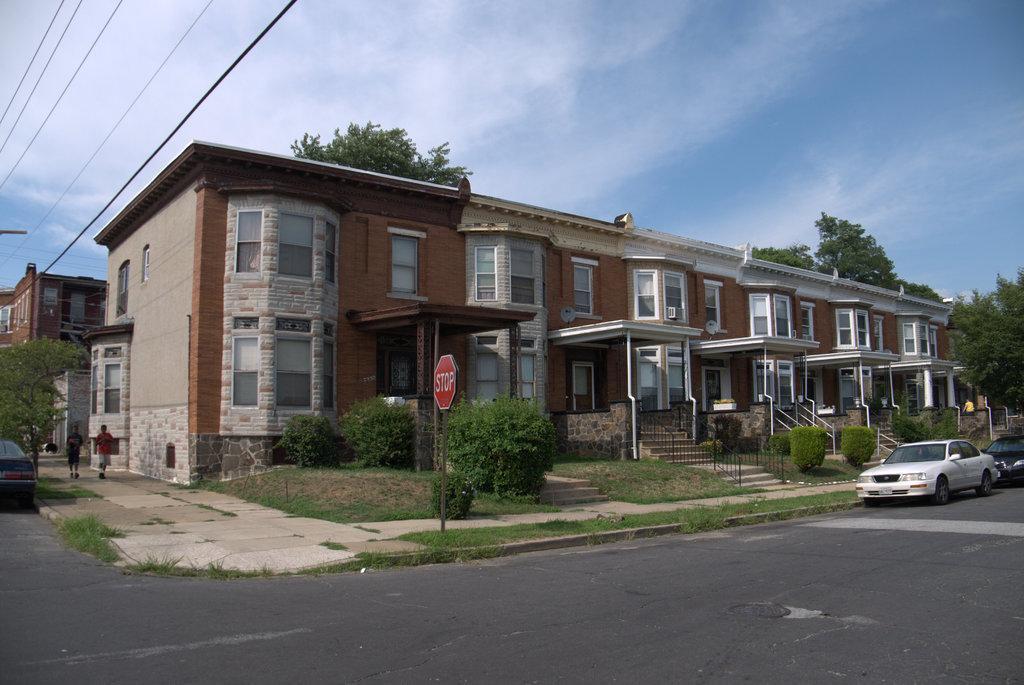Can you describe this image briefly? In this image we can see buildings, staircases, railings, sign boards, motor vehicles on the road, persons walking on the floor, electric cables, trees and sky with clouds. 